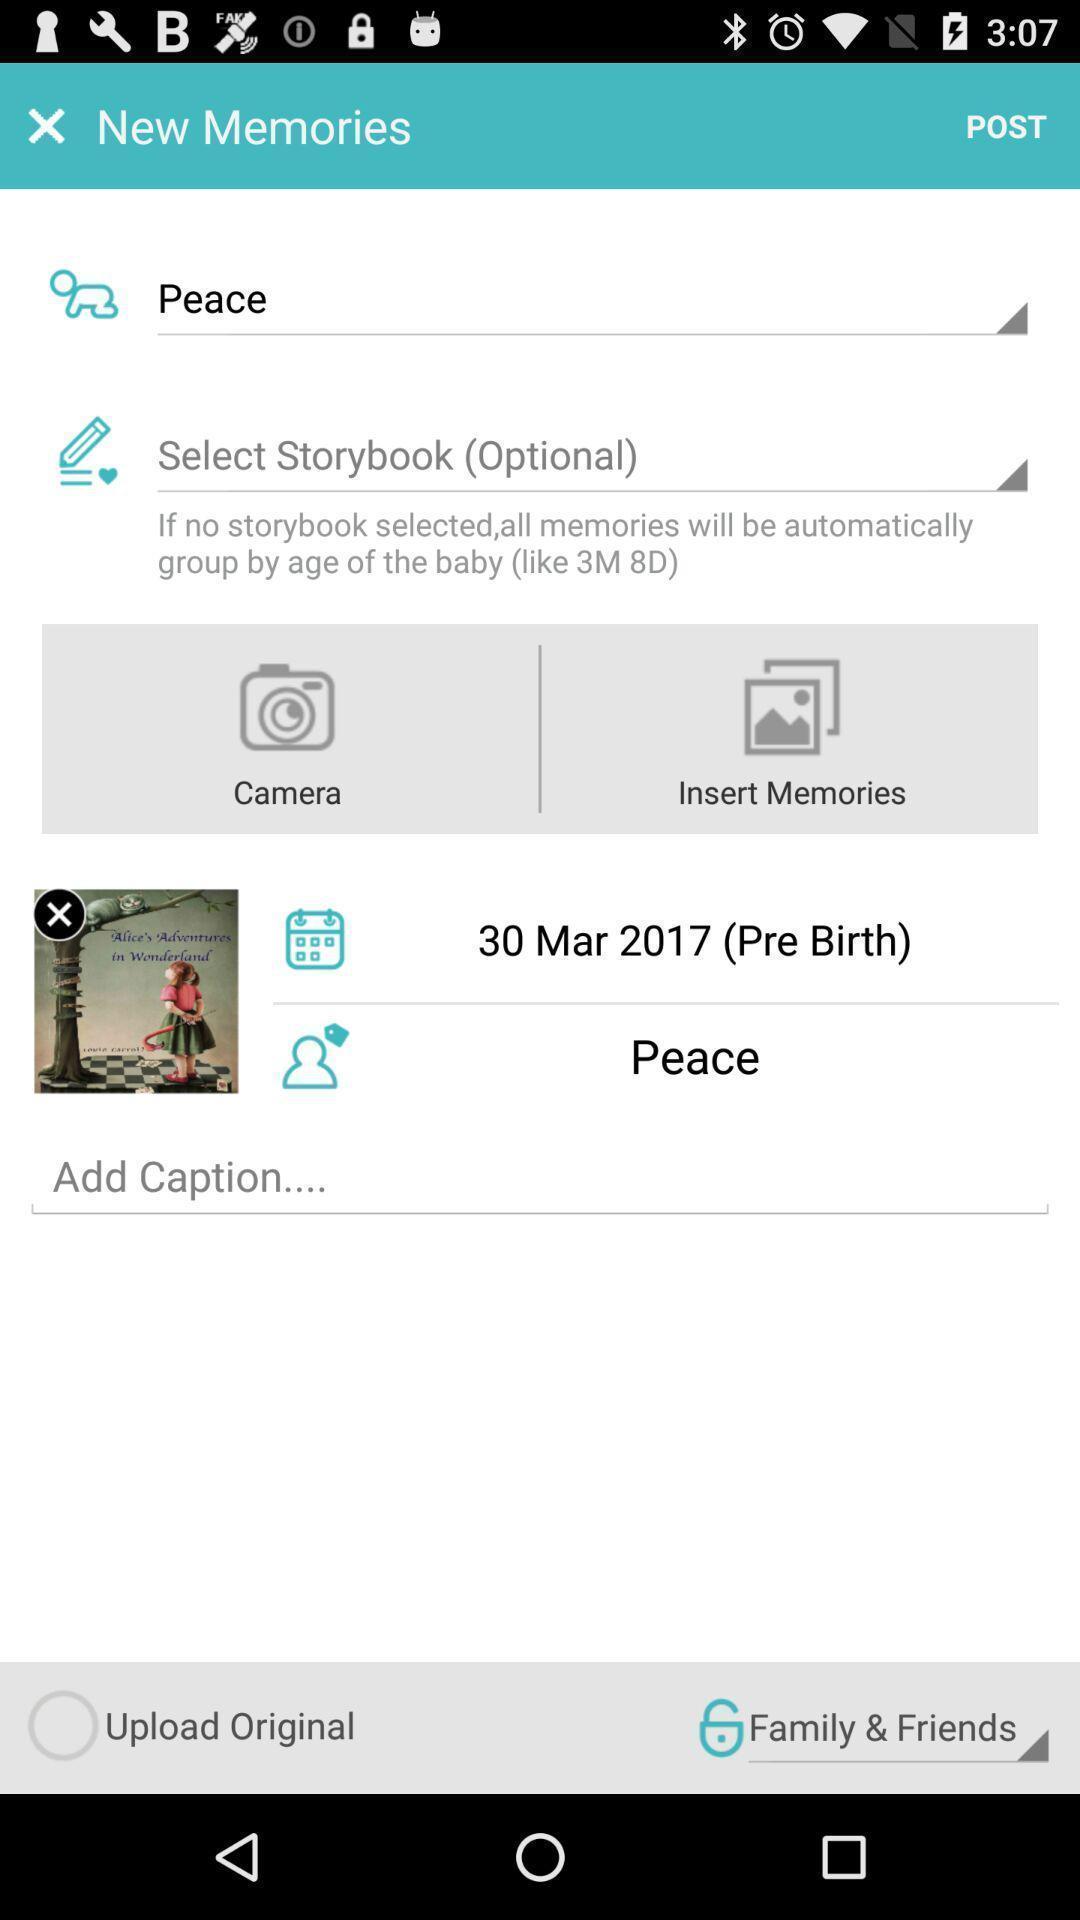Give me a summary of this screen capture. Page displaying to enter details for application with few options. 